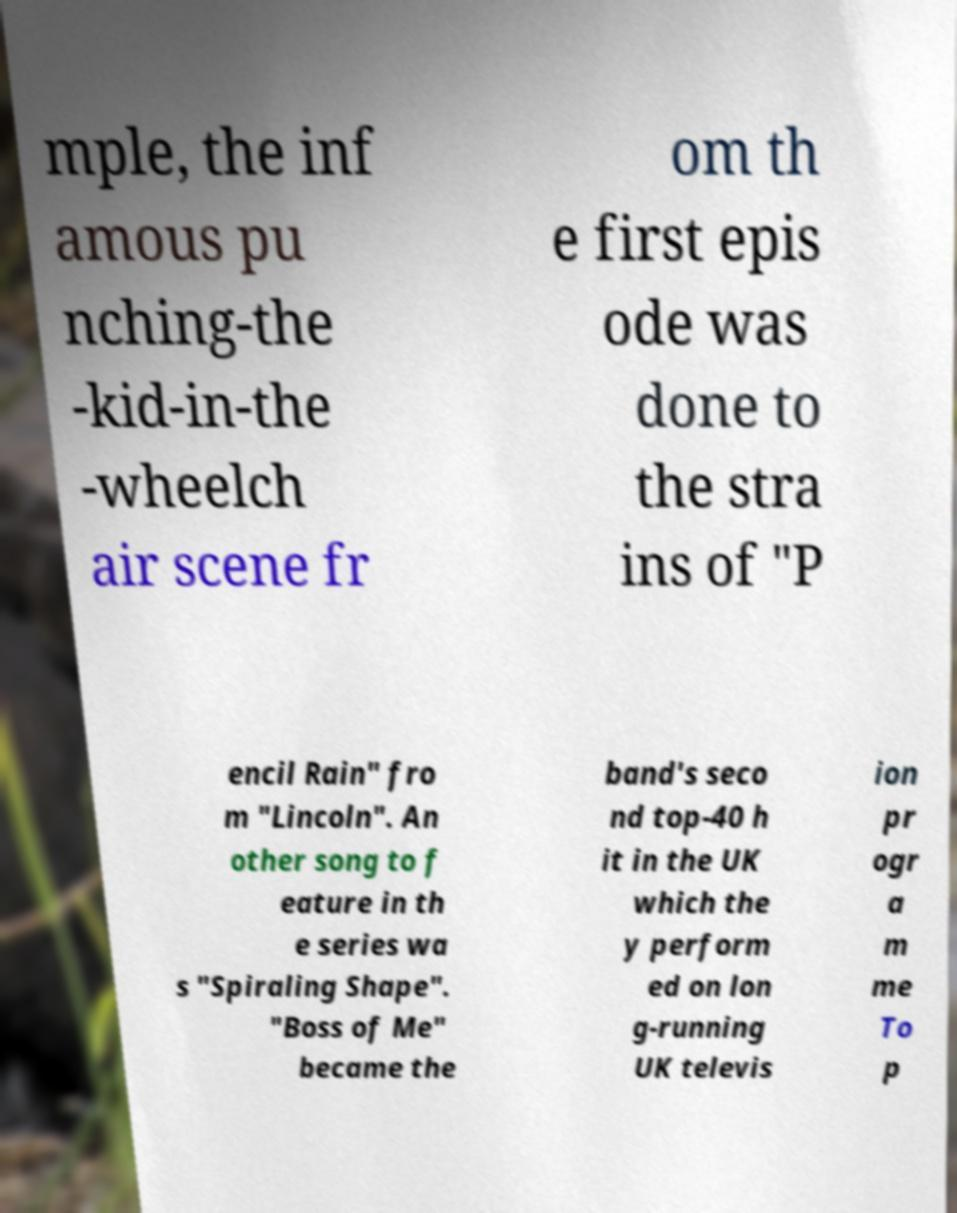Could you extract and type out the text from this image? mple, the inf amous pu nching-the -kid-in-the -wheelch air scene fr om th e first epis ode was done to the stra ins of "P encil Rain" fro m "Lincoln". An other song to f eature in th e series wa s "Spiraling Shape". "Boss of Me" became the band's seco nd top-40 h it in the UK which the y perform ed on lon g-running UK televis ion pr ogr a m me To p 